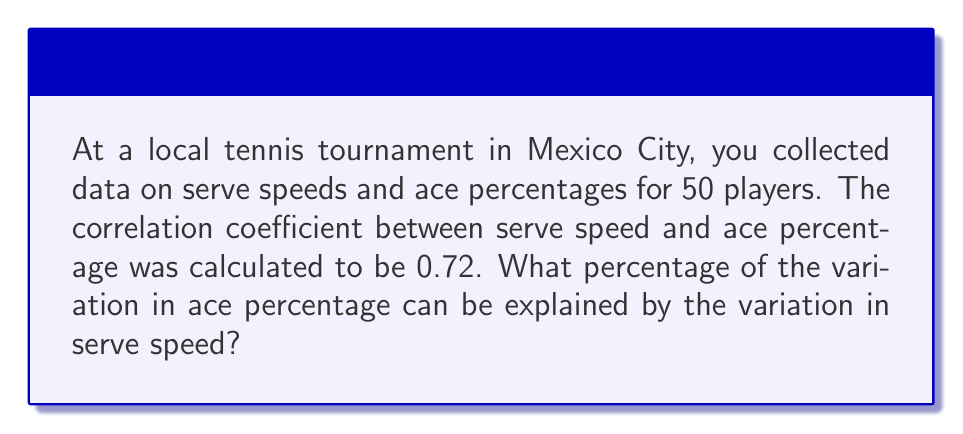Show me your answer to this math problem. To solve this problem, we need to understand the concept of the coefficient of determination, also known as R-squared (R²). This value represents the proportion of variance in the dependent variable (ace percentage) that is predictable from the independent variable (serve speed).

Step 1: Recall that the correlation coefficient (r) is the square root of R².
$r = \sqrt{R^2}$

Step 2: We are given the correlation coefficient (r) of 0.72. To find R², we need to square this value.
$R^2 = r^2 = 0.72^2 = 0.5184$

Step 3: Convert the decimal to a percentage by multiplying by 100.
$0.5184 \times 100 = 51.84\%$

Therefore, approximately 51.84% of the variation in ace percentage can be explained by the variation in serve speed.
Answer: 51.84% 